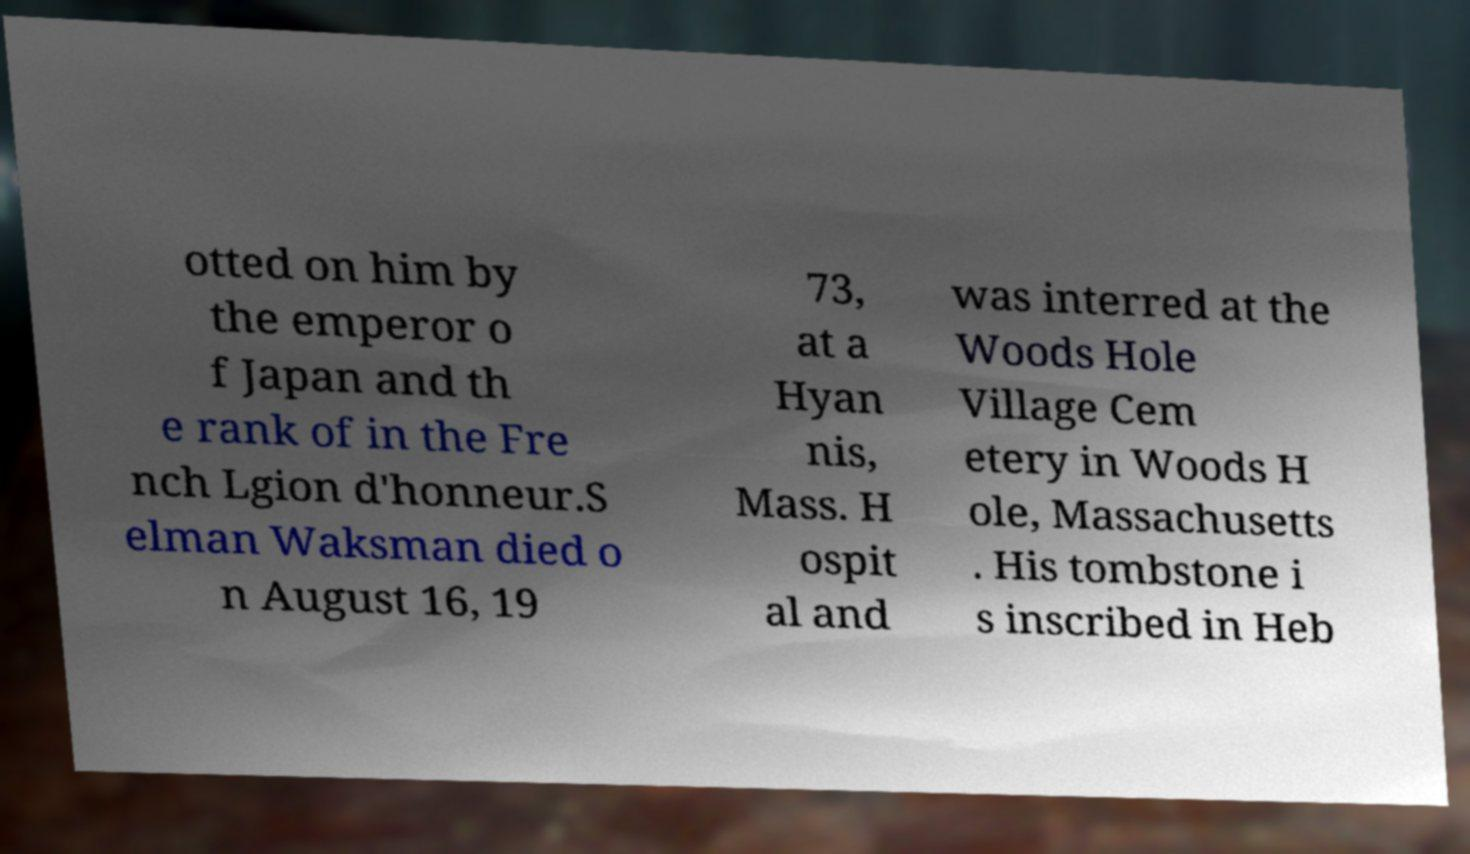There's text embedded in this image that I need extracted. Can you transcribe it verbatim? otted on him by the emperor o f Japan and th e rank of in the Fre nch Lgion d'honneur.S elman Waksman died o n August 16, 19 73, at a Hyan nis, Mass. H ospit al and was interred at the Woods Hole Village Cem etery in Woods H ole, Massachusetts . His tombstone i s inscribed in Heb 